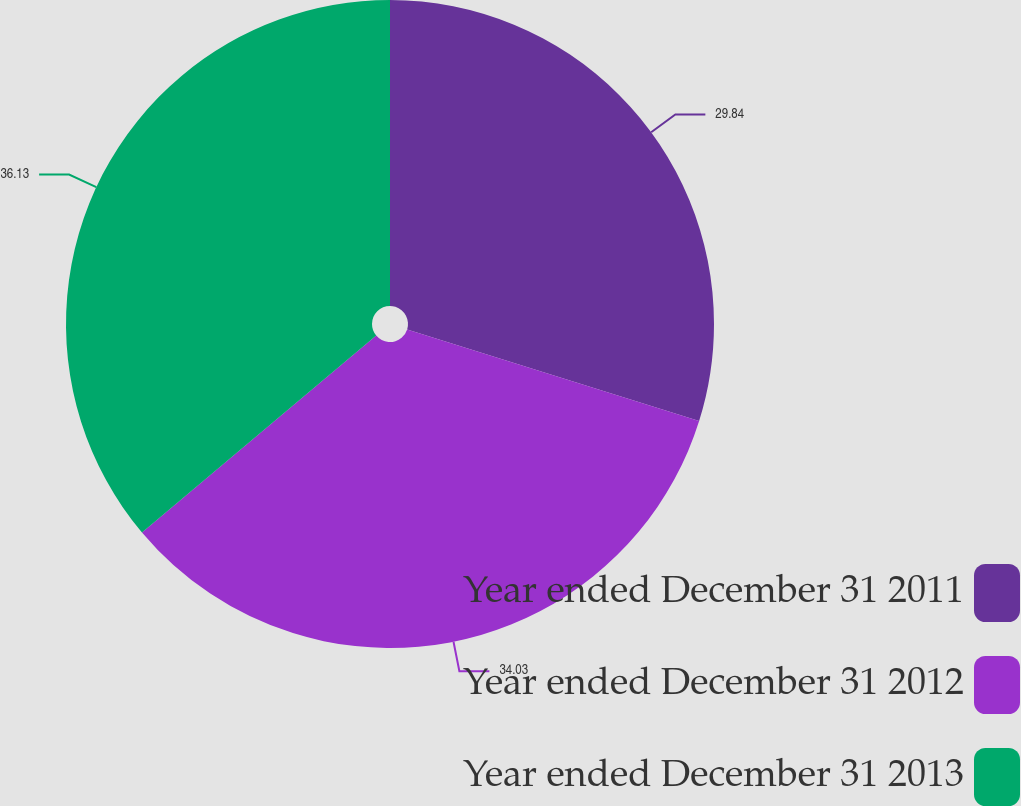Convert chart. <chart><loc_0><loc_0><loc_500><loc_500><pie_chart><fcel>Year ended December 31 2011<fcel>Year ended December 31 2012<fcel>Year ended December 31 2013<nl><fcel>29.84%<fcel>34.03%<fcel>36.12%<nl></chart> 